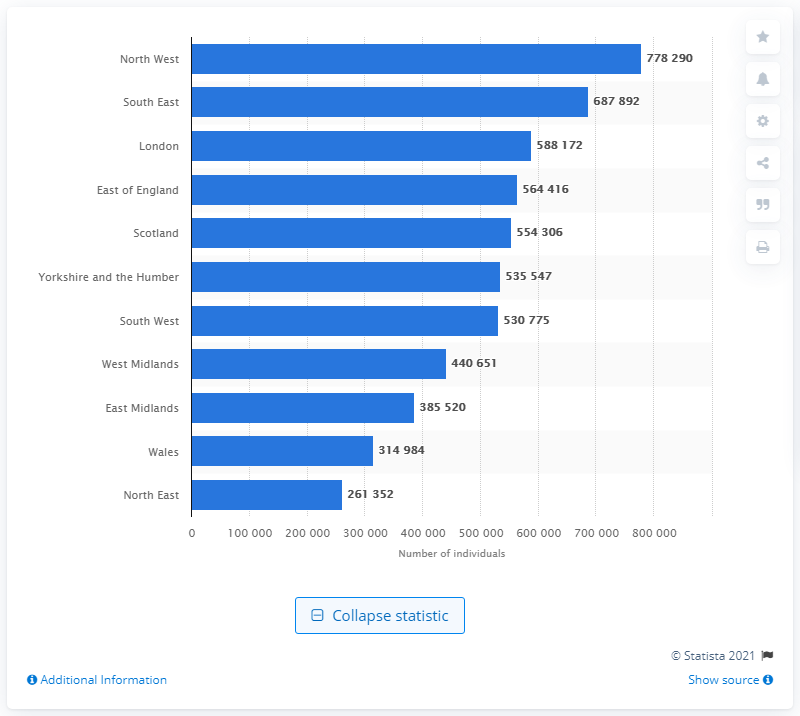Indicate a few pertinent items in this graphic. In 2015, it is estimated that approximately 778,290 people in the North West of England had asthma. In 2015, it is estimated that approximately 687,892 people in the South East region of the United States had asthma. 